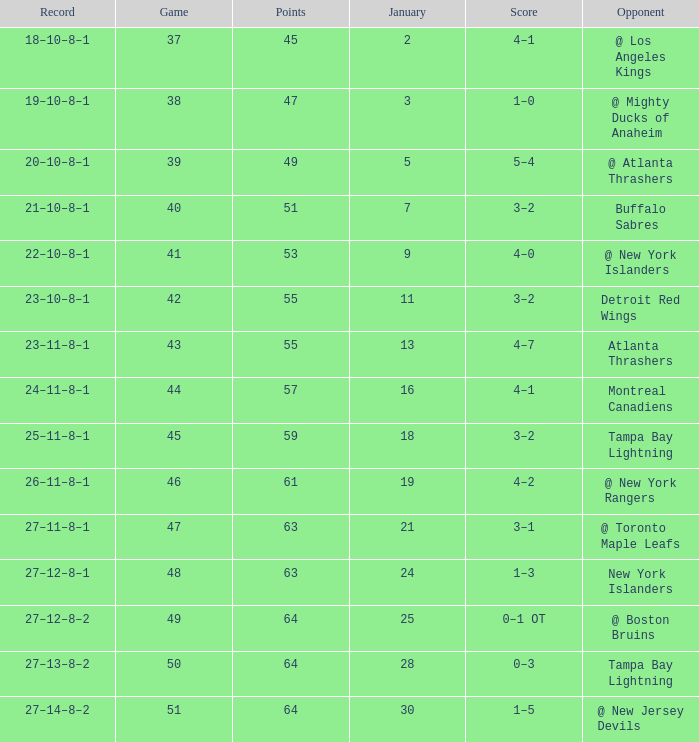Help me parse the entirety of this table. {'header': ['Record', 'Game', 'Points', 'January', 'Score', 'Opponent'], 'rows': [['18–10–8–1', '37', '45', '2', '4–1', '@ Los Angeles Kings'], ['19–10–8–1', '38', '47', '3', '1–0', '@ Mighty Ducks of Anaheim'], ['20–10–8–1', '39', '49', '5', '5–4', '@ Atlanta Thrashers'], ['21–10–8–1', '40', '51', '7', '3–2', 'Buffalo Sabres'], ['22–10–8–1', '41', '53', '9', '4–0', '@ New York Islanders'], ['23–10–8–1', '42', '55', '11', '3–2', 'Detroit Red Wings'], ['23–11–8–1', '43', '55', '13', '4–7', 'Atlanta Thrashers'], ['24–11–8–1', '44', '57', '16', '4–1', 'Montreal Canadiens'], ['25–11–8–1', '45', '59', '18', '3–2', 'Tampa Bay Lightning'], ['26–11–8–1', '46', '61', '19', '4–2', '@ New York Rangers'], ['27–11–8–1', '47', '63', '21', '3–1', '@ Toronto Maple Leafs'], ['27–12–8–1', '48', '63', '24', '1–3', 'New York Islanders'], ['27–12–8–2', '49', '64', '25', '0–1 OT', '@ Boston Bruins'], ['27–13–8–2', '50', '64', '28', '0–3', 'Tampa Bay Lightning'], ['27–14–8–2', '51', '64', '30', '1–5', '@ New Jersey Devils']]} How many Games have a Score of 5–4, and Points smaller than 49? 0.0. 